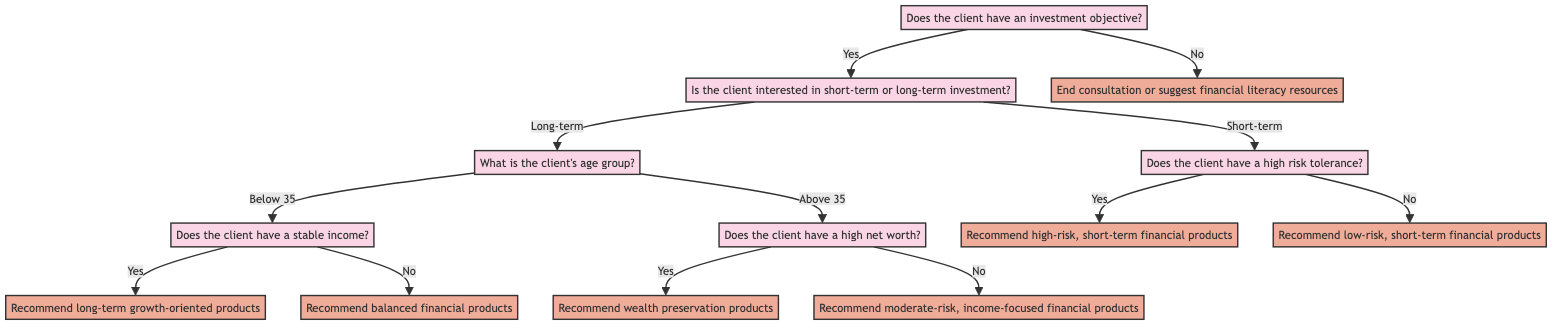What happens if the client does not have an investment objective? If the client does not have an investment objective, the diagram directs to the node that recommends ending the consultation or suggesting financial literacy resources.
Answer: End consultation or suggest financial literacy resources How many main paths are there from the start node? From the start node, there are two main paths: one for clients who have an investment objective (yes) and one for those who do not (no).
Answer: 2 What type of product is recommended for clients below 35 with a stable income? For clients below 35 with a stable income, the recommendation flows to the node that suggests long-term growth-oriented products like Equity Mutual Funds or Index Funds.
Answer: Recommend long-term growth-oriented products If a client wants a short-term investment and has low risk tolerance, what action does the diagram suggest? If a client is interested in short-term investment and has low risk tolerance, the flow leads to the node that recommends low-risk, short-term financial products like High-Yield Savings Accounts or Short-Term Bonds.
Answer: Recommend low-risk, short-term financial products What is recommended for older clients with high net worth? The diagram indicates that older clients with high net worth should be directed to wealth preservation products like Real Estate Investment Trusts or Blue-Chip Stocks.
Answer: Recommend wealth preservation products What question determines the type of long-term investment based on age? The diagram specifies that the question asking "What is the client's age group?" is used to determine the type of long-term investment recommended.
Answer: What is the client's age group? How does the decision change for clients who are above 35 years old? For clients above 35 years old, the decision tree directs to a different question about their net worth, which ultimately leads to different product recommendations based on whether they have a high or average net worth.
Answer: It leads to questions about net worth 